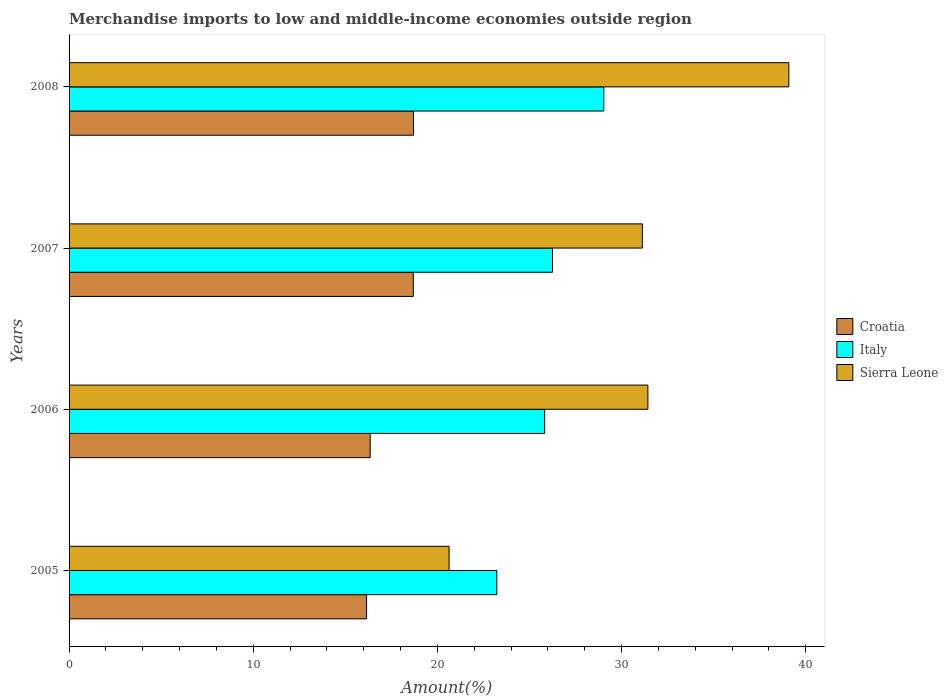How many different coloured bars are there?
Make the answer very short. 3. Are the number of bars on each tick of the Y-axis equal?
Your answer should be compact. Yes. What is the label of the 1st group of bars from the top?
Offer a very short reply. 2008. In how many cases, is the number of bars for a given year not equal to the number of legend labels?
Provide a succinct answer. 0. What is the percentage of amount earned from merchandise imports in Sierra Leone in 2007?
Provide a succinct answer. 31.13. Across all years, what is the maximum percentage of amount earned from merchandise imports in Sierra Leone?
Your answer should be compact. 39.09. Across all years, what is the minimum percentage of amount earned from merchandise imports in Croatia?
Keep it short and to the point. 16.16. What is the total percentage of amount earned from merchandise imports in Croatia in the graph?
Provide a succinct answer. 69.91. What is the difference between the percentage of amount earned from merchandise imports in Italy in 2006 and that in 2007?
Keep it short and to the point. -0.43. What is the difference between the percentage of amount earned from merchandise imports in Croatia in 2006 and the percentage of amount earned from merchandise imports in Sierra Leone in 2005?
Ensure brevity in your answer.  -4.28. What is the average percentage of amount earned from merchandise imports in Sierra Leone per year?
Give a very brief answer. 30.57. In the year 2008, what is the difference between the percentage of amount earned from merchandise imports in Sierra Leone and percentage of amount earned from merchandise imports in Croatia?
Offer a very short reply. 20.38. What is the ratio of the percentage of amount earned from merchandise imports in Italy in 2005 to that in 2007?
Your response must be concise. 0.88. Is the difference between the percentage of amount earned from merchandise imports in Sierra Leone in 2006 and 2007 greater than the difference between the percentage of amount earned from merchandise imports in Croatia in 2006 and 2007?
Provide a succinct answer. Yes. What is the difference between the highest and the second highest percentage of amount earned from merchandise imports in Sierra Leone?
Offer a terse response. 7.66. What is the difference between the highest and the lowest percentage of amount earned from merchandise imports in Croatia?
Provide a succinct answer. 2.55. In how many years, is the percentage of amount earned from merchandise imports in Croatia greater than the average percentage of amount earned from merchandise imports in Croatia taken over all years?
Provide a short and direct response. 2. Is the sum of the percentage of amount earned from merchandise imports in Sierra Leone in 2007 and 2008 greater than the maximum percentage of amount earned from merchandise imports in Italy across all years?
Make the answer very short. Yes. Is it the case that in every year, the sum of the percentage of amount earned from merchandise imports in Italy and percentage of amount earned from merchandise imports in Croatia is greater than the percentage of amount earned from merchandise imports in Sierra Leone?
Provide a succinct answer. Yes. Are all the bars in the graph horizontal?
Provide a succinct answer. Yes. How many years are there in the graph?
Your answer should be very brief. 4. What is the difference between two consecutive major ticks on the X-axis?
Your response must be concise. 10. Are the values on the major ticks of X-axis written in scientific E-notation?
Your response must be concise. No. Where does the legend appear in the graph?
Your answer should be very brief. Center right. How many legend labels are there?
Offer a terse response. 3. How are the legend labels stacked?
Your answer should be very brief. Vertical. What is the title of the graph?
Provide a succinct answer. Merchandise imports to low and middle-income economies outside region. Does "Spain" appear as one of the legend labels in the graph?
Offer a very short reply. No. What is the label or title of the X-axis?
Your answer should be compact. Amount(%). What is the label or title of the Y-axis?
Offer a very short reply. Years. What is the Amount(%) in Croatia in 2005?
Provide a succinct answer. 16.16. What is the Amount(%) of Italy in 2005?
Offer a terse response. 23.23. What is the Amount(%) of Sierra Leone in 2005?
Offer a very short reply. 20.64. What is the Amount(%) of Croatia in 2006?
Offer a terse response. 16.35. What is the Amount(%) in Italy in 2006?
Your answer should be compact. 25.83. What is the Amount(%) of Sierra Leone in 2006?
Your response must be concise. 31.43. What is the Amount(%) of Croatia in 2007?
Your response must be concise. 18.69. What is the Amount(%) of Italy in 2007?
Your answer should be very brief. 26.25. What is the Amount(%) in Sierra Leone in 2007?
Your answer should be compact. 31.13. What is the Amount(%) of Croatia in 2008?
Offer a very short reply. 18.7. What is the Amount(%) in Italy in 2008?
Offer a very short reply. 29.04. What is the Amount(%) of Sierra Leone in 2008?
Make the answer very short. 39.09. Across all years, what is the maximum Amount(%) in Croatia?
Your response must be concise. 18.7. Across all years, what is the maximum Amount(%) of Italy?
Make the answer very short. 29.04. Across all years, what is the maximum Amount(%) in Sierra Leone?
Ensure brevity in your answer.  39.09. Across all years, what is the minimum Amount(%) in Croatia?
Your answer should be compact. 16.16. Across all years, what is the minimum Amount(%) in Italy?
Offer a very short reply. 23.23. Across all years, what is the minimum Amount(%) in Sierra Leone?
Offer a very short reply. 20.64. What is the total Amount(%) of Croatia in the graph?
Provide a succinct answer. 69.91. What is the total Amount(%) of Italy in the graph?
Provide a short and direct response. 104.34. What is the total Amount(%) of Sierra Leone in the graph?
Offer a very short reply. 122.28. What is the difference between the Amount(%) in Croatia in 2005 and that in 2006?
Offer a terse response. -0.2. What is the difference between the Amount(%) of Italy in 2005 and that in 2006?
Your response must be concise. -2.6. What is the difference between the Amount(%) of Sierra Leone in 2005 and that in 2006?
Offer a terse response. -10.8. What is the difference between the Amount(%) in Croatia in 2005 and that in 2007?
Your response must be concise. -2.54. What is the difference between the Amount(%) of Italy in 2005 and that in 2007?
Provide a short and direct response. -3.02. What is the difference between the Amount(%) in Sierra Leone in 2005 and that in 2007?
Offer a terse response. -10.5. What is the difference between the Amount(%) in Croatia in 2005 and that in 2008?
Provide a succinct answer. -2.55. What is the difference between the Amount(%) in Italy in 2005 and that in 2008?
Give a very brief answer. -5.81. What is the difference between the Amount(%) of Sierra Leone in 2005 and that in 2008?
Give a very brief answer. -18.45. What is the difference between the Amount(%) in Croatia in 2006 and that in 2007?
Provide a short and direct response. -2.34. What is the difference between the Amount(%) of Italy in 2006 and that in 2007?
Make the answer very short. -0.43. What is the difference between the Amount(%) in Sierra Leone in 2006 and that in 2007?
Your answer should be compact. 0.3. What is the difference between the Amount(%) of Croatia in 2006 and that in 2008?
Your response must be concise. -2.35. What is the difference between the Amount(%) of Italy in 2006 and that in 2008?
Offer a very short reply. -3.21. What is the difference between the Amount(%) of Sierra Leone in 2006 and that in 2008?
Offer a very short reply. -7.66. What is the difference between the Amount(%) of Croatia in 2007 and that in 2008?
Provide a short and direct response. -0.01. What is the difference between the Amount(%) of Italy in 2007 and that in 2008?
Provide a succinct answer. -2.79. What is the difference between the Amount(%) in Sierra Leone in 2007 and that in 2008?
Keep it short and to the point. -7.96. What is the difference between the Amount(%) in Croatia in 2005 and the Amount(%) in Italy in 2006?
Offer a terse response. -9.67. What is the difference between the Amount(%) of Croatia in 2005 and the Amount(%) of Sierra Leone in 2006?
Offer a very short reply. -15.28. What is the difference between the Amount(%) in Italy in 2005 and the Amount(%) in Sierra Leone in 2006?
Give a very brief answer. -8.2. What is the difference between the Amount(%) of Croatia in 2005 and the Amount(%) of Italy in 2007?
Ensure brevity in your answer.  -10.1. What is the difference between the Amount(%) in Croatia in 2005 and the Amount(%) in Sierra Leone in 2007?
Offer a very short reply. -14.97. What is the difference between the Amount(%) of Italy in 2005 and the Amount(%) of Sierra Leone in 2007?
Offer a very short reply. -7.9. What is the difference between the Amount(%) in Croatia in 2005 and the Amount(%) in Italy in 2008?
Give a very brief answer. -12.88. What is the difference between the Amount(%) in Croatia in 2005 and the Amount(%) in Sierra Leone in 2008?
Keep it short and to the point. -22.93. What is the difference between the Amount(%) of Italy in 2005 and the Amount(%) of Sierra Leone in 2008?
Provide a succinct answer. -15.86. What is the difference between the Amount(%) in Croatia in 2006 and the Amount(%) in Italy in 2007?
Your response must be concise. -9.9. What is the difference between the Amount(%) in Croatia in 2006 and the Amount(%) in Sierra Leone in 2007?
Offer a terse response. -14.78. What is the difference between the Amount(%) of Italy in 2006 and the Amount(%) of Sierra Leone in 2007?
Your answer should be very brief. -5.31. What is the difference between the Amount(%) in Croatia in 2006 and the Amount(%) in Italy in 2008?
Keep it short and to the point. -12.69. What is the difference between the Amount(%) of Croatia in 2006 and the Amount(%) of Sierra Leone in 2008?
Keep it short and to the point. -22.73. What is the difference between the Amount(%) of Italy in 2006 and the Amount(%) of Sierra Leone in 2008?
Your answer should be compact. -13.26. What is the difference between the Amount(%) in Croatia in 2007 and the Amount(%) in Italy in 2008?
Provide a succinct answer. -10.35. What is the difference between the Amount(%) of Croatia in 2007 and the Amount(%) of Sierra Leone in 2008?
Offer a terse response. -20.39. What is the difference between the Amount(%) in Italy in 2007 and the Amount(%) in Sierra Leone in 2008?
Offer a terse response. -12.84. What is the average Amount(%) in Croatia per year?
Offer a very short reply. 17.48. What is the average Amount(%) in Italy per year?
Your response must be concise. 26.09. What is the average Amount(%) of Sierra Leone per year?
Provide a short and direct response. 30.57. In the year 2005, what is the difference between the Amount(%) of Croatia and Amount(%) of Italy?
Keep it short and to the point. -7.07. In the year 2005, what is the difference between the Amount(%) in Croatia and Amount(%) in Sierra Leone?
Your response must be concise. -4.48. In the year 2005, what is the difference between the Amount(%) in Italy and Amount(%) in Sierra Leone?
Your answer should be compact. 2.59. In the year 2006, what is the difference between the Amount(%) in Croatia and Amount(%) in Italy?
Your answer should be very brief. -9.47. In the year 2006, what is the difference between the Amount(%) of Croatia and Amount(%) of Sierra Leone?
Offer a very short reply. -15.08. In the year 2006, what is the difference between the Amount(%) of Italy and Amount(%) of Sierra Leone?
Your answer should be very brief. -5.61. In the year 2007, what is the difference between the Amount(%) of Croatia and Amount(%) of Italy?
Offer a very short reply. -7.56. In the year 2007, what is the difference between the Amount(%) of Croatia and Amount(%) of Sierra Leone?
Offer a terse response. -12.44. In the year 2007, what is the difference between the Amount(%) in Italy and Amount(%) in Sierra Leone?
Give a very brief answer. -4.88. In the year 2008, what is the difference between the Amount(%) of Croatia and Amount(%) of Italy?
Keep it short and to the point. -10.33. In the year 2008, what is the difference between the Amount(%) in Croatia and Amount(%) in Sierra Leone?
Your answer should be compact. -20.38. In the year 2008, what is the difference between the Amount(%) in Italy and Amount(%) in Sierra Leone?
Offer a very short reply. -10.05. What is the ratio of the Amount(%) of Italy in 2005 to that in 2006?
Your answer should be very brief. 0.9. What is the ratio of the Amount(%) of Sierra Leone in 2005 to that in 2006?
Keep it short and to the point. 0.66. What is the ratio of the Amount(%) of Croatia in 2005 to that in 2007?
Provide a short and direct response. 0.86. What is the ratio of the Amount(%) of Italy in 2005 to that in 2007?
Your response must be concise. 0.88. What is the ratio of the Amount(%) of Sierra Leone in 2005 to that in 2007?
Your response must be concise. 0.66. What is the ratio of the Amount(%) in Croatia in 2005 to that in 2008?
Your answer should be very brief. 0.86. What is the ratio of the Amount(%) in Italy in 2005 to that in 2008?
Make the answer very short. 0.8. What is the ratio of the Amount(%) of Sierra Leone in 2005 to that in 2008?
Offer a very short reply. 0.53. What is the ratio of the Amount(%) of Croatia in 2006 to that in 2007?
Your answer should be compact. 0.87. What is the ratio of the Amount(%) of Italy in 2006 to that in 2007?
Provide a short and direct response. 0.98. What is the ratio of the Amount(%) in Sierra Leone in 2006 to that in 2007?
Make the answer very short. 1.01. What is the ratio of the Amount(%) of Croatia in 2006 to that in 2008?
Offer a very short reply. 0.87. What is the ratio of the Amount(%) of Italy in 2006 to that in 2008?
Give a very brief answer. 0.89. What is the ratio of the Amount(%) of Sierra Leone in 2006 to that in 2008?
Offer a terse response. 0.8. What is the ratio of the Amount(%) in Croatia in 2007 to that in 2008?
Make the answer very short. 1. What is the ratio of the Amount(%) in Italy in 2007 to that in 2008?
Keep it short and to the point. 0.9. What is the ratio of the Amount(%) in Sierra Leone in 2007 to that in 2008?
Make the answer very short. 0.8. What is the difference between the highest and the second highest Amount(%) of Croatia?
Your answer should be compact. 0.01. What is the difference between the highest and the second highest Amount(%) in Italy?
Keep it short and to the point. 2.79. What is the difference between the highest and the second highest Amount(%) in Sierra Leone?
Offer a very short reply. 7.66. What is the difference between the highest and the lowest Amount(%) in Croatia?
Offer a very short reply. 2.55. What is the difference between the highest and the lowest Amount(%) of Italy?
Give a very brief answer. 5.81. What is the difference between the highest and the lowest Amount(%) in Sierra Leone?
Ensure brevity in your answer.  18.45. 